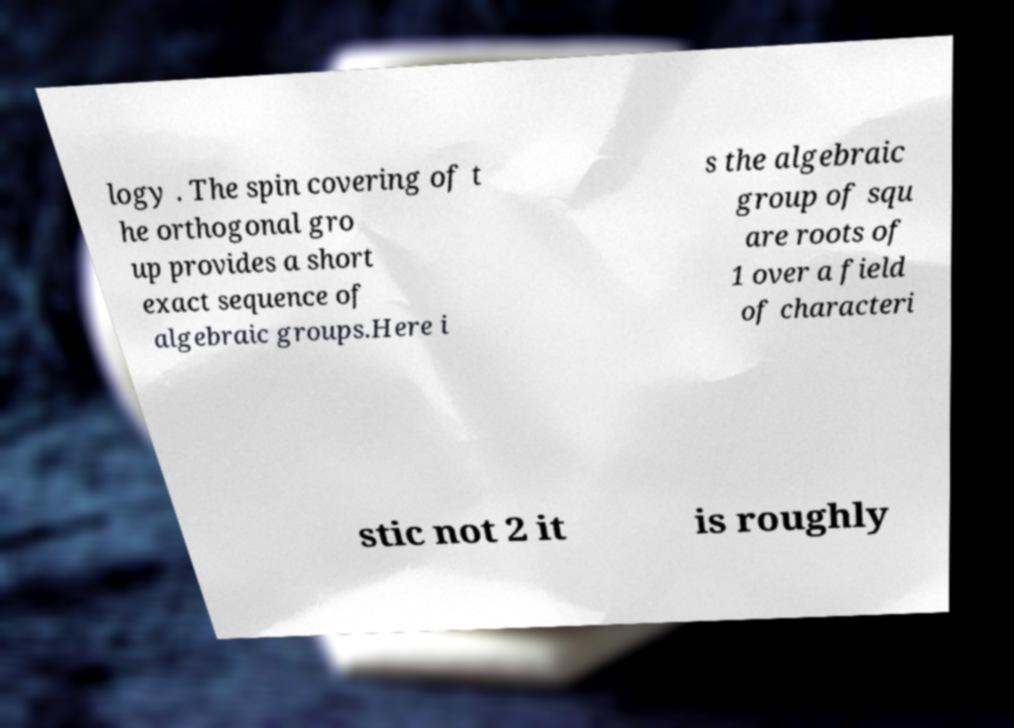There's text embedded in this image that I need extracted. Can you transcribe it verbatim? logy . The spin covering of t he orthogonal gro up provides a short exact sequence of algebraic groups.Here i s the algebraic group of squ are roots of 1 over a field of characteri stic not 2 it is roughly 